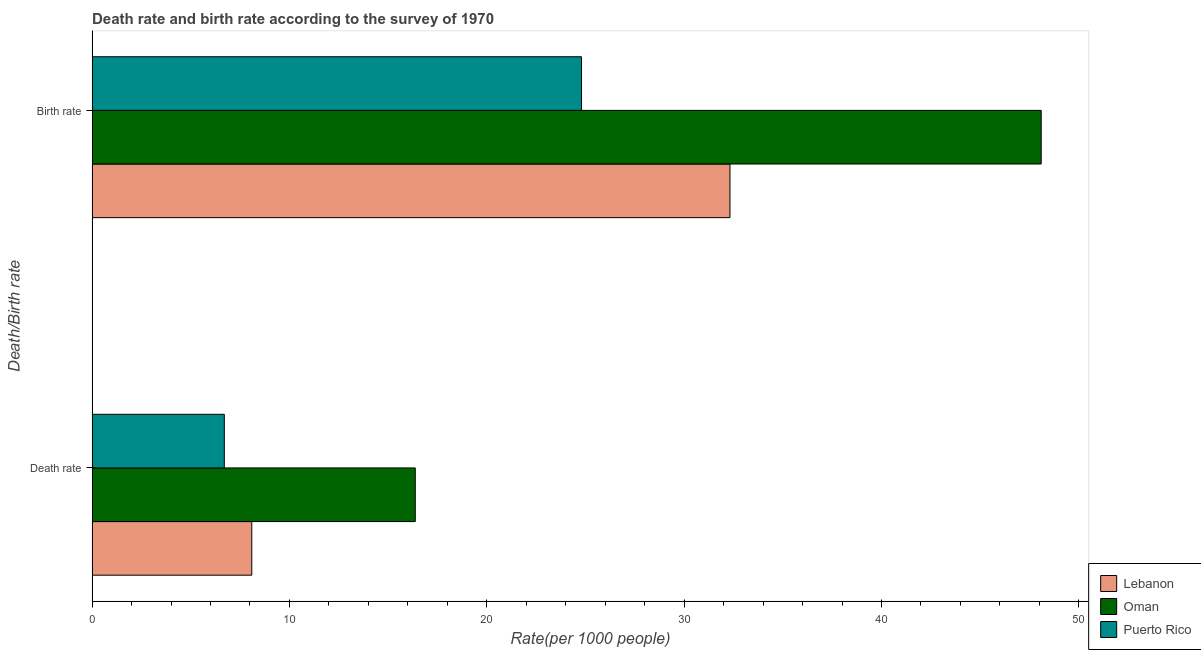How many different coloured bars are there?
Ensure brevity in your answer.  3. How many groups of bars are there?
Offer a terse response. 2. Are the number of bars per tick equal to the number of legend labels?
Make the answer very short. Yes. How many bars are there on the 2nd tick from the top?
Your answer should be compact. 3. What is the label of the 1st group of bars from the top?
Make the answer very short. Birth rate. What is the birth rate in Puerto Rico?
Offer a very short reply. 24.8. Across all countries, what is the maximum death rate?
Offer a terse response. 16.38. Across all countries, what is the minimum death rate?
Your response must be concise. 6.7. In which country was the death rate maximum?
Your answer should be very brief. Oman. In which country was the death rate minimum?
Give a very brief answer. Puerto Rico. What is the total birth rate in the graph?
Your answer should be compact. 105.22. What is the difference between the death rate in Puerto Rico and that in Oman?
Give a very brief answer. -9.68. What is the difference between the death rate in Puerto Rico and the birth rate in Oman?
Your response must be concise. -41.39. What is the average birth rate per country?
Provide a short and direct response. 35.07. What is the difference between the death rate and birth rate in Puerto Rico?
Make the answer very short. -18.1. In how many countries, is the death rate greater than 32 ?
Offer a terse response. 0. What is the ratio of the death rate in Oman to that in Puerto Rico?
Keep it short and to the point. 2.44. Is the birth rate in Lebanon less than that in Oman?
Provide a succinct answer. Yes. What does the 2nd bar from the top in Death rate represents?
Offer a terse response. Oman. What does the 3rd bar from the bottom in Birth rate represents?
Offer a terse response. Puerto Rico. Are all the bars in the graph horizontal?
Ensure brevity in your answer.  Yes. What is the difference between two consecutive major ticks on the X-axis?
Keep it short and to the point. 10. Does the graph contain any zero values?
Give a very brief answer. No. Does the graph contain grids?
Give a very brief answer. No. Where does the legend appear in the graph?
Offer a terse response. Bottom right. What is the title of the graph?
Your answer should be compact. Death rate and birth rate according to the survey of 1970. Does "Mexico" appear as one of the legend labels in the graph?
Your answer should be very brief. No. What is the label or title of the X-axis?
Provide a short and direct response. Rate(per 1000 people). What is the label or title of the Y-axis?
Provide a succinct answer. Death/Birth rate. What is the Rate(per 1000 people) in Lebanon in Death rate?
Give a very brief answer. 8.09. What is the Rate(per 1000 people) in Oman in Death rate?
Your answer should be very brief. 16.38. What is the Rate(per 1000 people) in Lebanon in Birth rate?
Provide a short and direct response. 32.32. What is the Rate(per 1000 people) of Oman in Birth rate?
Offer a terse response. 48.09. What is the Rate(per 1000 people) of Puerto Rico in Birth rate?
Offer a very short reply. 24.8. Across all Death/Birth rate, what is the maximum Rate(per 1000 people) in Lebanon?
Keep it short and to the point. 32.32. Across all Death/Birth rate, what is the maximum Rate(per 1000 people) of Oman?
Provide a short and direct response. 48.09. Across all Death/Birth rate, what is the maximum Rate(per 1000 people) of Puerto Rico?
Give a very brief answer. 24.8. Across all Death/Birth rate, what is the minimum Rate(per 1000 people) of Lebanon?
Your answer should be compact. 8.09. Across all Death/Birth rate, what is the minimum Rate(per 1000 people) of Oman?
Provide a short and direct response. 16.38. What is the total Rate(per 1000 people) in Lebanon in the graph?
Offer a terse response. 40.41. What is the total Rate(per 1000 people) of Oman in the graph?
Provide a short and direct response. 64.47. What is the total Rate(per 1000 people) in Puerto Rico in the graph?
Ensure brevity in your answer.  31.5. What is the difference between the Rate(per 1000 people) of Lebanon in Death rate and that in Birth rate?
Keep it short and to the point. -24.23. What is the difference between the Rate(per 1000 people) in Oman in Death rate and that in Birth rate?
Offer a terse response. -31.72. What is the difference between the Rate(per 1000 people) in Puerto Rico in Death rate and that in Birth rate?
Give a very brief answer. -18.1. What is the difference between the Rate(per 1000 people) in Lebanon in Death rate and the Rate(per 1000 people) in Oman in Birth rate?
Ensure brevity in your answer.  -40. What is the difference between the Rate(per 1000 people) of Lebanon in Death rate and the Rate(per 1000 people) of Puerto Rico in Birth rate?
Provide a short and direct response. -16.71. What is the difference between the Rate(per 1000 people) of Oman in Death rate and the Rate(per 1000 people) of Puerto Rico in Birth rate?
Make the answer very short. -8.42. What is the average Rate(per 1000 people) of Lebanon per Death/Birth rate?
Make the answer very short. 20.21. What is the average Rate(per 1000 people) of Oman per Death/Birth rate?
Ensure brevity in your answer.  32.23. What is the average Rate(per 1000 people) of Puerto Rico per Death/Birth rate?
Offer a terse response. 15.75. What is the difference between the Rate(per 1000 people) in Lebanon and Rate(per 1000 people) in Oman in Death rate?
Give a very brief answer. -8.28. What is the difference between the Rate(per 1000 people) in Lebanon and Rate(per 1000 people) in Puerto Rico in Death rate?
Your answer should be very brief. 1.39. What is the difference between the Rate(per 1000 people) of Oman and Rate(per 1000 people) of Puerto Rico in Death rate?
Provide a succinct answer. 9.68. What is the difference between the Rate(per 1000 people) of Lebanon and Rate(per 1000 people) of Oman in Birth rate?
Make the answer very short. -15.77. What is the difference between the Rate(per 1000 people) in Lebanon and Rate(per 1000 people) in Puerto Rico in Birth rate?
Ensure brevity in your answer.  7.52. What is the difference between the Rate(per 1000 people) of Oman and Rate(per 1000 people) of Puerto Rico in Birth rate?
Your response must be concise. 23.29. What is the ratio of the Rate(per 1000 people) of Lebanon in Death rate to that in Birth rate?
Provide a succinct answer. 0.25. What is the ratio of the Rate(per 1000 people) of Oman in Death rate to that in Birth rate?
Provide a short and direct response. 0.34. What is the ratio of the Rate(per 1000 people) in Puerto Rico in Death rate to that in Birth rate?
Your answer should be very brief. 0.27. What is the difference between the highest and the second highest Rate(per 1000 people) of Lebanon?
Ensure brevity in your answer.  24.23. What is the difference between the highest and the second highest Rate(per 1000 people) in Oman?
Provide a succinct answer. 31.72. What is the difference between the highest and the second highest Rate(per 1000 people) of Puerto Rico?
Offer a very short reply. 18.1. What is the difference between the highest and the lowest Rate(per 1000 people) in Lebanon?
Keep it short and to the point. 24.23. What is the difference between the highest and the lowest Rate(per 1000 people) of Oman?
Provide a succinct answer. 31.72. What is the difference between the highest and the lowest Rate(per 1000 people) of Puerto Rico?
Give a very brief answer. 18.1. 